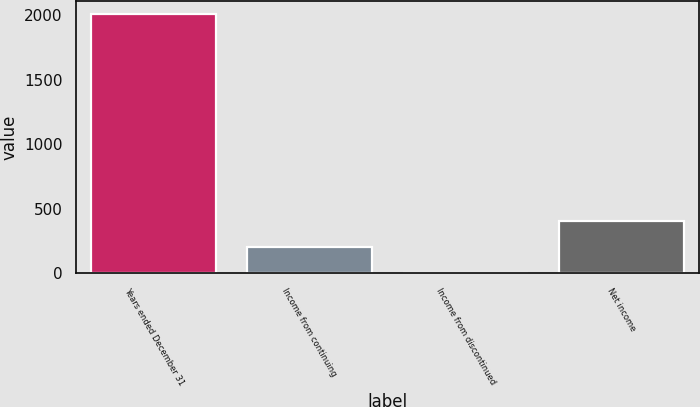Convert chart to OTSL. <chart><loc_0><loc_0><loc_500><loc_500><bar_chart><fcel>Years ended December 31<fcel>Income from continuing<fcel>Income from discontinued<fcel>Net income<nl><fcel>2007<fcel>205.2<fcel>5<fcel>405.4<nl></chart> 